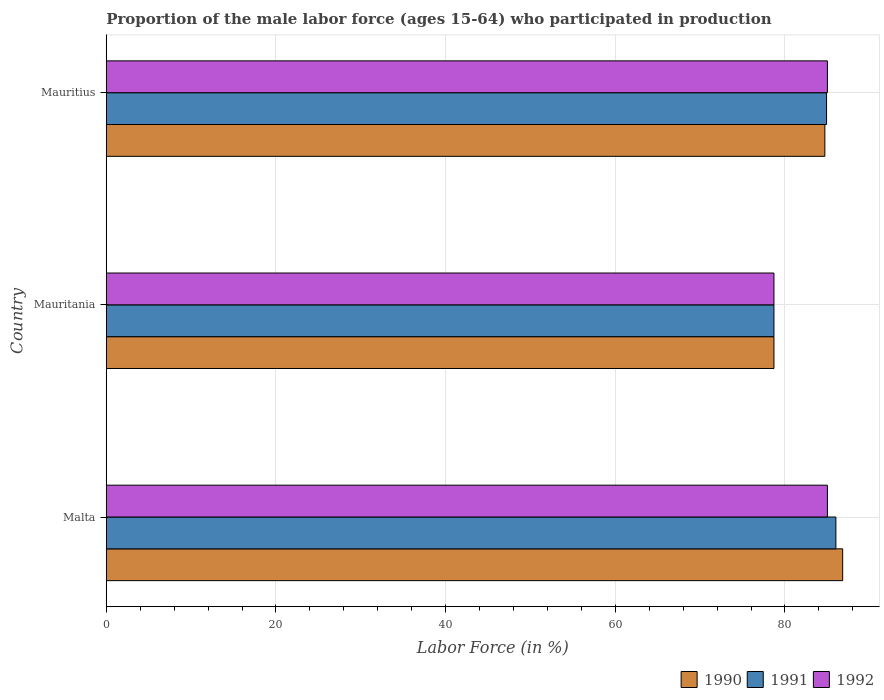How many bars are there on the 1st tick from the bottom?
Your answer should be very brief. 3. What is the label of the 2nd group of bars from the top?
Give a very brief answer. Mauritania. What is the proportion of the male labor force who participated in production in 1991 in Mauritania?
Your answer should be very brief. 78.7. Across all countries, what is the minimum proportion of the male labor force who participated in production in 1990?
Offer a very short reply. 78.7. In which country was the proportion of the male labor force who participated in production in 1990 maximum?
Make the answer very short. Malta. In which country was the proportion of the male labor force who participated in production in 1991 minimum?
Make the answer very short. Mauritania. What is the total proportion of the male labor force who participated in production in 1991 in the graph?
Make the answer very short. 249.6. What is the difference between the proportion of the male labor force who participated in production in 1992 in Malta and that in Mauritania?
Provide a succinct answer. 6.3. What is the average proportion of the male labor force who participated in production in 1990 per country?
Provide a short and direct response. 83.4. In how many countries, is the proportion of the male labor force who participated in production in 1992 greater than 48 %?
Ensure brevity in your answer.  3. What is the ratio of the proportion of the male labor force who participated in production in 1992 in Malta to that in Mauritius?
Ensure brevity in your answer.  1. Is the difference between the proportion of the male labor force who participated in production in 1990 in Mauritania and Mauritius greater than the difference between the proportion of the male labor force who participated in production in 1991 in Mauritania and Mauritius?
Make the answer very short. Yes. What is the difference between the highest and the second highest proportion of the male labor force who participated in production in 1992?
Ensure brevity in your answer.  0. What is the difference between the highest and the lowest proportion of the male labor force who participated in production in 1990?
Offer a very short reply. 8.1. In how many countries, is the proportion of the male labor force who participated in production in 1991 greater than the average proportion of the male labor force who participated in production in 1991 taken over all countries?
Provide a short and direct response. 2. What does the 3rd bar from the top in Mauritius represents?
Ensure brevity in your answer.  1990. How many bars are there?
Make the answer very short. 9. How many countries are there in the graph?
Make the answer very short. 3. Does the graph contain any zero values?
Your answer should be very brief. No. Does the graph contain grids?
Offer a very short reply. Yes. Where does the legend appear in the graph?
Your response must be concise. Bottom right. How many legend labels are there?
Provide a short and direct response. 3. What is the title of the graph?
Offer a very short reply. Proportion of the male labor force (ages 15-64) who participated in production. Does "2010" appear as one of the legend labels in the graph?
Offer a very short reply. No. What is the label or title of the X-axis?
Make the answer very short. Labor Force (in %). What is the label or title of the Y-axis?
Provide a short and direct response. Country. What is the Labor Force (in %) in 1990 in Malta?
Your response must be concise. 86.8. What is the Labor Force (in %) in 1992 in Malta?
Make the answer very short. 85. What is the Labor Force (in %) of 1990 in Mauritania?
Your answer should be very brief. 78.7. What is the Labor Force (in %) in 1991 in Mauritania?
Make the answer very short. 78.7. What is the Labor Force (in %) in 1992 in Mauritania?
Give a very brief answer. 78.7. What is the Labor Force (in %) in 1990 in Mauritius?
Your answer should be very brief. 84.7. What is the Labor Force (in %) in 1991 in Mauritius?
Offer a very short reply. 84.9. Across all countries, what is the maximum Labor Force (in %) in 1990?
Make the answer very short. 86.8. Across all countries, what is the maximum Labor Force (in %) of 1991?
Keep it short and to the point. 86. Across all countries, what is the minimum Labor Force (in %) in 1990?
Provide a succinct answer. 78.7. Across all countries, what is the minimum Labor Force (in %) of 1991?
Ensure brevity in your answer.  78.7. Across all countries, what is the minimum Labor Force (in %) in 1992?
Provide a short and direct response. 78.7. What is the total Labor Force (in %) in 1990 in the graph?
Offer a very short reply. 250.2. What is the total Labor Force (in %) in 1991 in the graph?
Offer a terse response. 249.6. What is the total Labor Force (in %) in 1992 in the graph?
Offer a terse response. 248.7. What is the difference between the Labor Force (in %) of 1990 in Malta and that in Mauritania?
Keep it short and to the point. 8.1. What is the difference between the Labor Force (in %) of 1990 in Malta and that in Mauritius?
Your answer should be compact. 2.1. What is the difference between the Labor Force (in %) in 1992 in Malta and that in Mauritius?
Make the answer very short. 0. What is the difference between the Labor Force (in %) in 1990 in Mauritania and that in Mauritius?
Provide a short and direct response. -6. What is the difference between the Labor Force (in %) in 1991 in Mauritania and that in Mauritius?
Keep it short and to the point. -6.2. What is the difference between the Labor Force (in %) in 1992 in Mauritania and that in Mauritius?
Provide a short and direct response. -6.3. What is the difference between the Labor Force (in %) in 1991 in Malta and the Labor Force (in %) in 1992 in Mauritania?
Ensure brevity in your answer.  7.3. What is the difference between the Labor Force (in %) in 1990 in Malta and the Labor Force (in %) in 1992 in Mauritius?
Offer a terse response. 1.8. What is the difference between the Labor Force (in %) in 1991 in Malta and the Labor Force (in %) in 1992 in Mauritius?
Your answer should be compact. 1. What is the difference between the Labor Force (in %) in 1990 in Mauritania and the Labor Force (in %) in 1991 in Mauritius?
Offer a terse response. -6.2. What is the difference between the Labor Force (in %) of 1990 in Mauritania and the Labor Force (in %) of 1992 in Mauritius?
Your response must be concise. -6.3. What is the average Labor Force (in %) of 1990 per country?
Your response must be concise. 83.4. What is the average Labor Force (in %) of 1991 per country?
Provide a short and direct response. 83.2. What is the average Labor Force (in %) of 1992 per country?
Provide a short and direct response. 82.9. What is the difference between the Labor Force (in %) of 1991 and Labor Force (in %) of 1992 in Mauritania?
Keep it short and to the point. 0. What is the difference between the Labor Force (in %) in 1990 and Labor Force (in %) in 1991 in Mauritius?
Offer a terse response. -0.2. What is the ratio of the Labor Force (in %) in 1990 in Malta to that in Mauritania?
Your response must be concise. 1.1. What is the ratio of the Labor Force (in %) in 1991 in Malta to that in Mauritania?
Provide a short and direct response. 1.09. What is the ratio of the Labor Force (in %) in 1992 in Malta to that in Mauritania?
Make the answer very short. 1.08. What is the ratio of the Labor Force (in %) of 1990 in Malta to that in Mauritius?
Make the answer very short. 1.02. What is the ratio of the Labor Force (in %) of 1990 in Mauritania to that in Mauritius?
Your response must be concise. 0.93. What is the ratio of the Labor Force (in %) in 1991 in Mauritania to that in Mauritius?
Offer a terse response. 0.93. What is the ratio of the Labor Force (in %) in 1992 in Mauritania to that in Mauritius?
Offer a very short reply. 0.93. What is the difference between the highest and the second highest Labor Force (in %) in 1990?
Offer a very short reply. 2.1. What is the difference between the highest and the second highest Labor Force (in %) of 1991?
Keep it short and to the point. 1.1. What is the difference between the highest and the second highest Labor Force (in %) in 1992?
Your response must be concise. 0. What is the difference between the highest and the lowest Labor Force (in %) in 1990?
Ensure brevity in your answer.  8.1. What is the difference between the highest and the lowest Labor Force (in %) in 1991?
Offer a terse response. 7.3. 